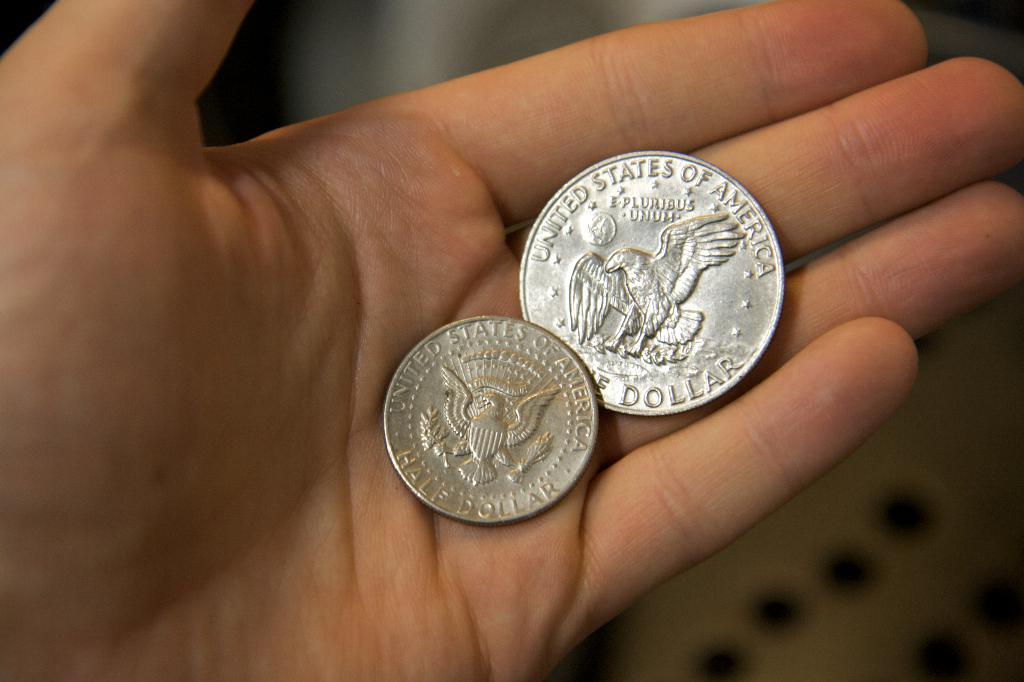How much money is that?
Make the answer very short. 1.50. What type of coin is that?
Offer a very short reply. Half dollar. 